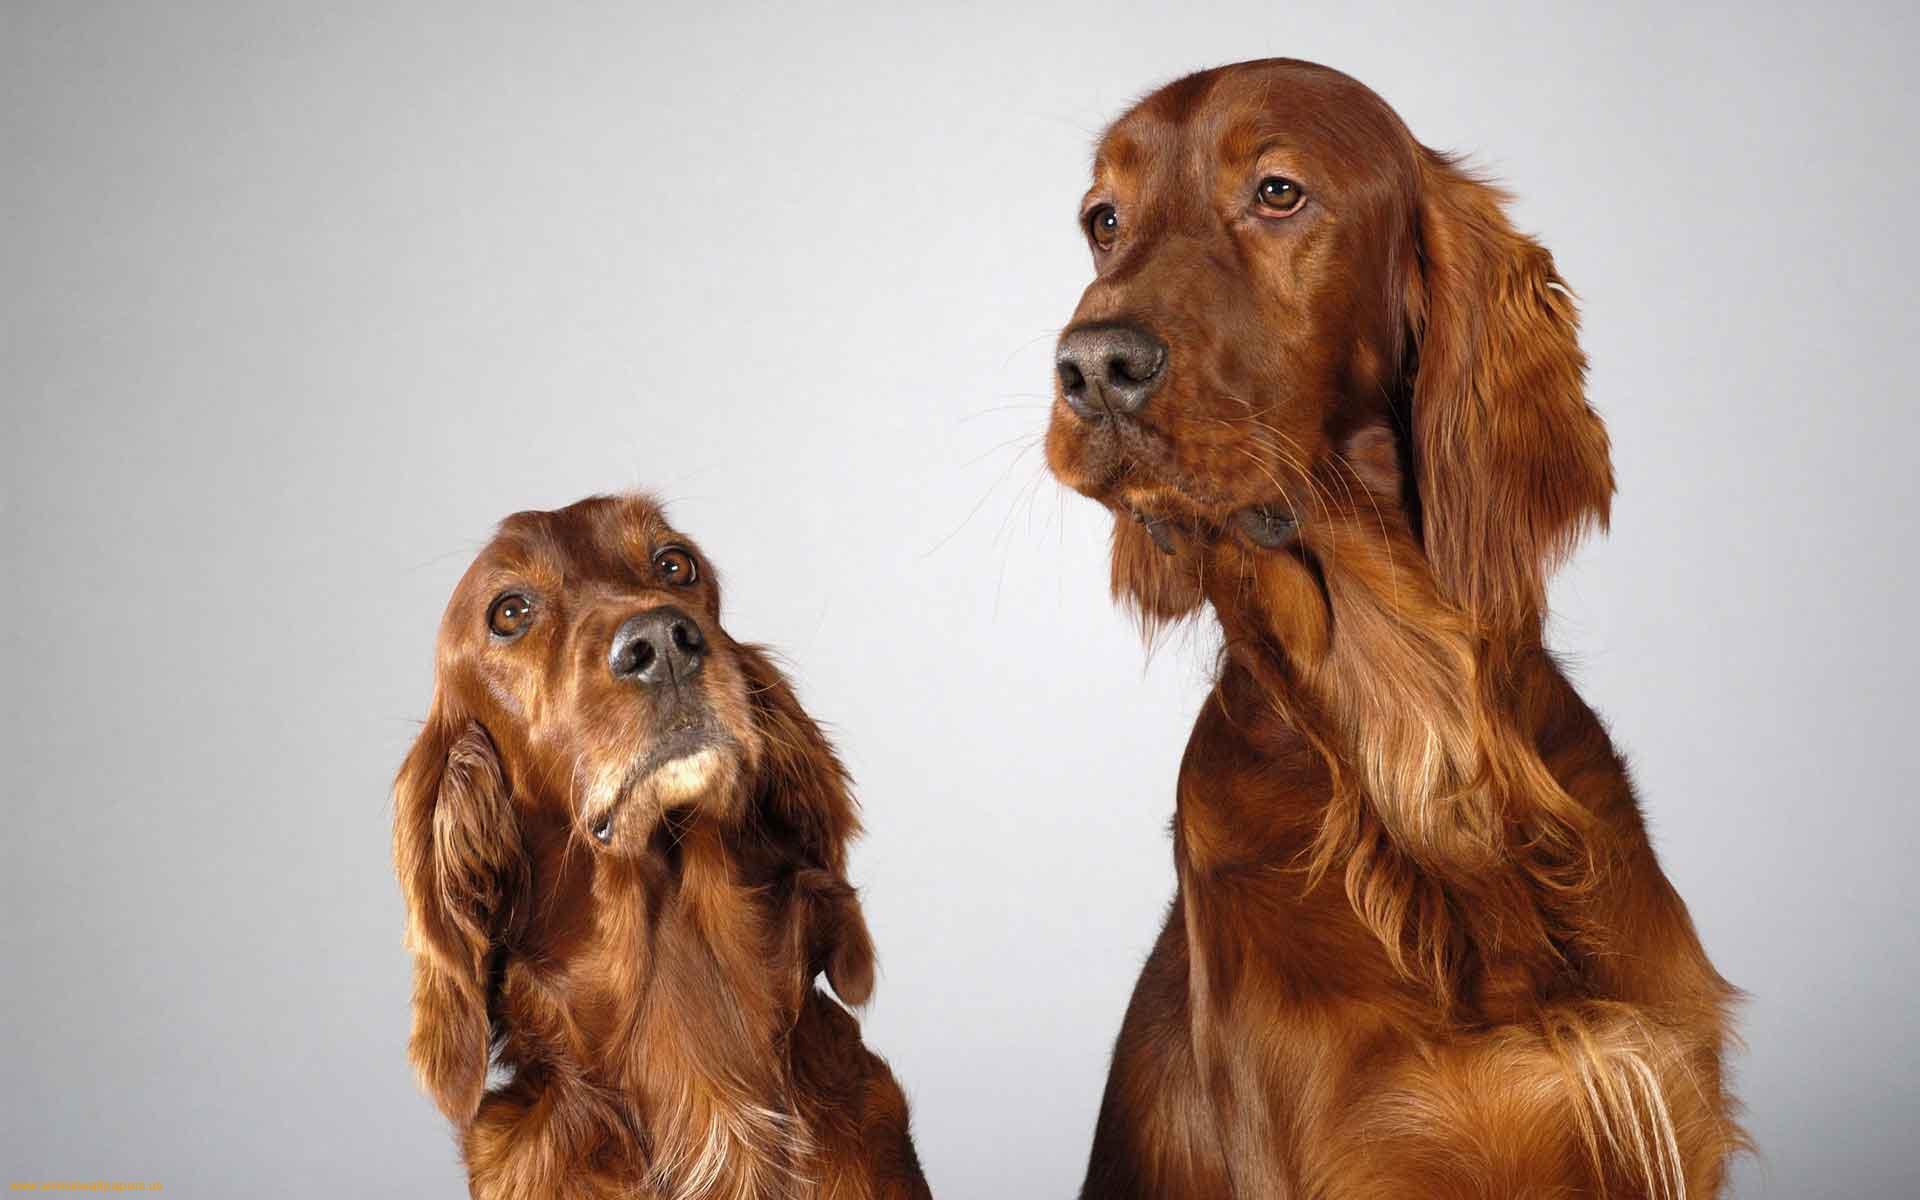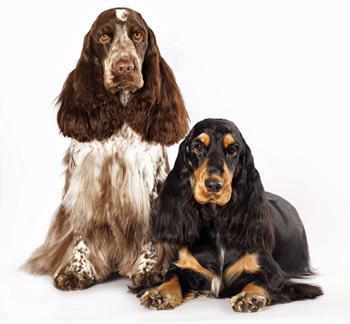The first image is the image on the left, the second image is the image on the right. Given the left and right images, does the statement "Each image contains a single spaniel dog, and the dogs in the left and right images have similar type body poses." hold true? Answer yes or no. No. The first image is the image on the left, the second image is the image on the right. Examine the images to the left and right. Is the description "There are at least three dogs in total." accurate? Answer yes or no. Yes. 